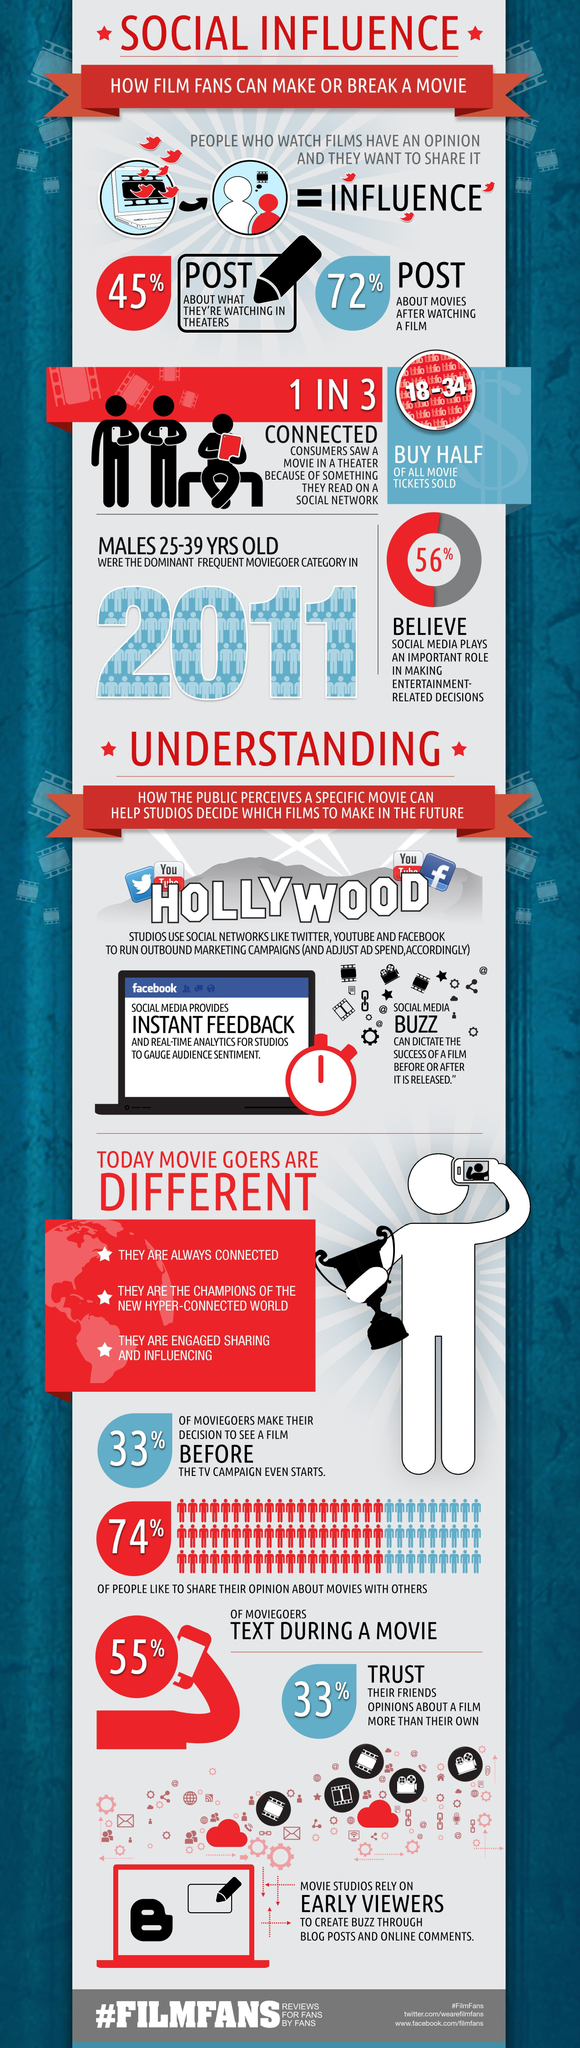What percent of people do not like sharing opinion about movies with others?
Answer the question with a short phrase. 26% Which age group buys half of all movie tickets sold? 18-34 What percent of people do not post about what they are watching in theatres? 55% 